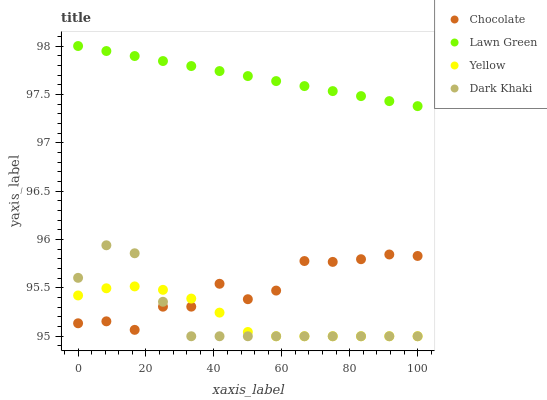Does Yellow have the minimum area under the curve?
Answer yes or no. Yes. Does Lawn Green have the maximum area under the curve?
Answer yes or no. Yes. Does Lawn Green have the minimum area under the curve?
Answer yes or no. No. Does Yellow have the maximum area under the curve?
Answer yes or no. No. Is Lawn Green the smoothest?
Answer yes or no. Yes. Is Chocolate the roughest?
Answer yes or no. Yes. Is Yellow the smoothest?
Answer yes or no. No. Is Yellow the roughest?
Answer yes or no. No. Does Dark Khaki have the lowest value?
Answer yes or no. Yes. Does Lawn Green have the lowest value?
Answer yes or no. No. Does Lawn Green have the highest value?
Answer yes or no. Yes. Does Yellow have the highest value?
Answer yes or no. No. Is Yellow less than Lawn Green?
Answer yes or no. Yes. Is Lawn Green greater than Chocolate?
Answer yes or no. Yes. Does Yellow intersect Chocolate?
Answer yes or no. Yes. Is Yellow less than Chocolate?
Answer yes or no. No. Is Yellow greater than Chocolate?
Answer yes or no. No. Does Yellow intersect Lawn Green?
Answer yes or no. No. 